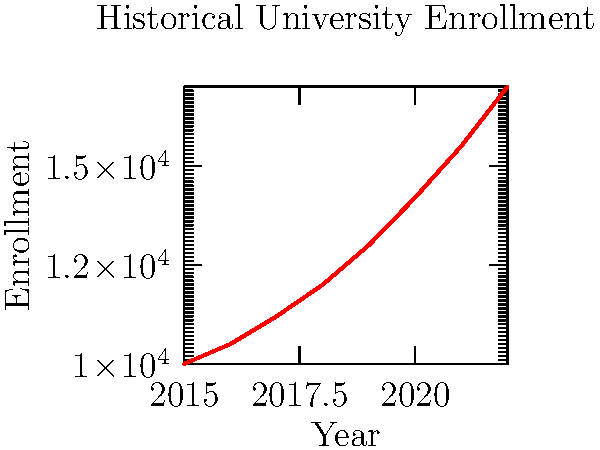Based on the line graph showing historical university enrollment data from 2015 to 2022, what would be a reasonable prediction for enrollment in 2023 if the trend continues? To predict the enrollment for 2023, we need to analyze the trend in the given data:

1. Observe the overall trend: The graph shows a clear upward trend in enrollment from 2015 to 2022.

2. Calculate the year-over-year increase:
   2015 to 2016: 500
   2016 to 2017: 700
   2017 to 2018: 800
   2018 to 2019: 1000
   2019 to 2020: 1200
   2020 to 2021: 1300
   2021 to 2022: 1500

3. Notice that the year-over-year increase is also growing each year.

4. The last observed increase (2021 to 2022) was 1500.

5. Given the accelerating growth, we can estimate that the increase from 2022 to 2023 might be slightly higher, around 1600-1700.

6. The enrollment in 2022 was 17000.

7. Therefore, a reasonable prediction for 2023 would be:
   17000 + 1600 to 1700 ≈ 18600 to 18700

8. Rounding to the nearest hundred, we can predict an enrollment of about 18700 for 2023.
Answer: 18700 